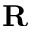<formula> <loc_0><loc_0><loc_500><loc_500>R</formula> 